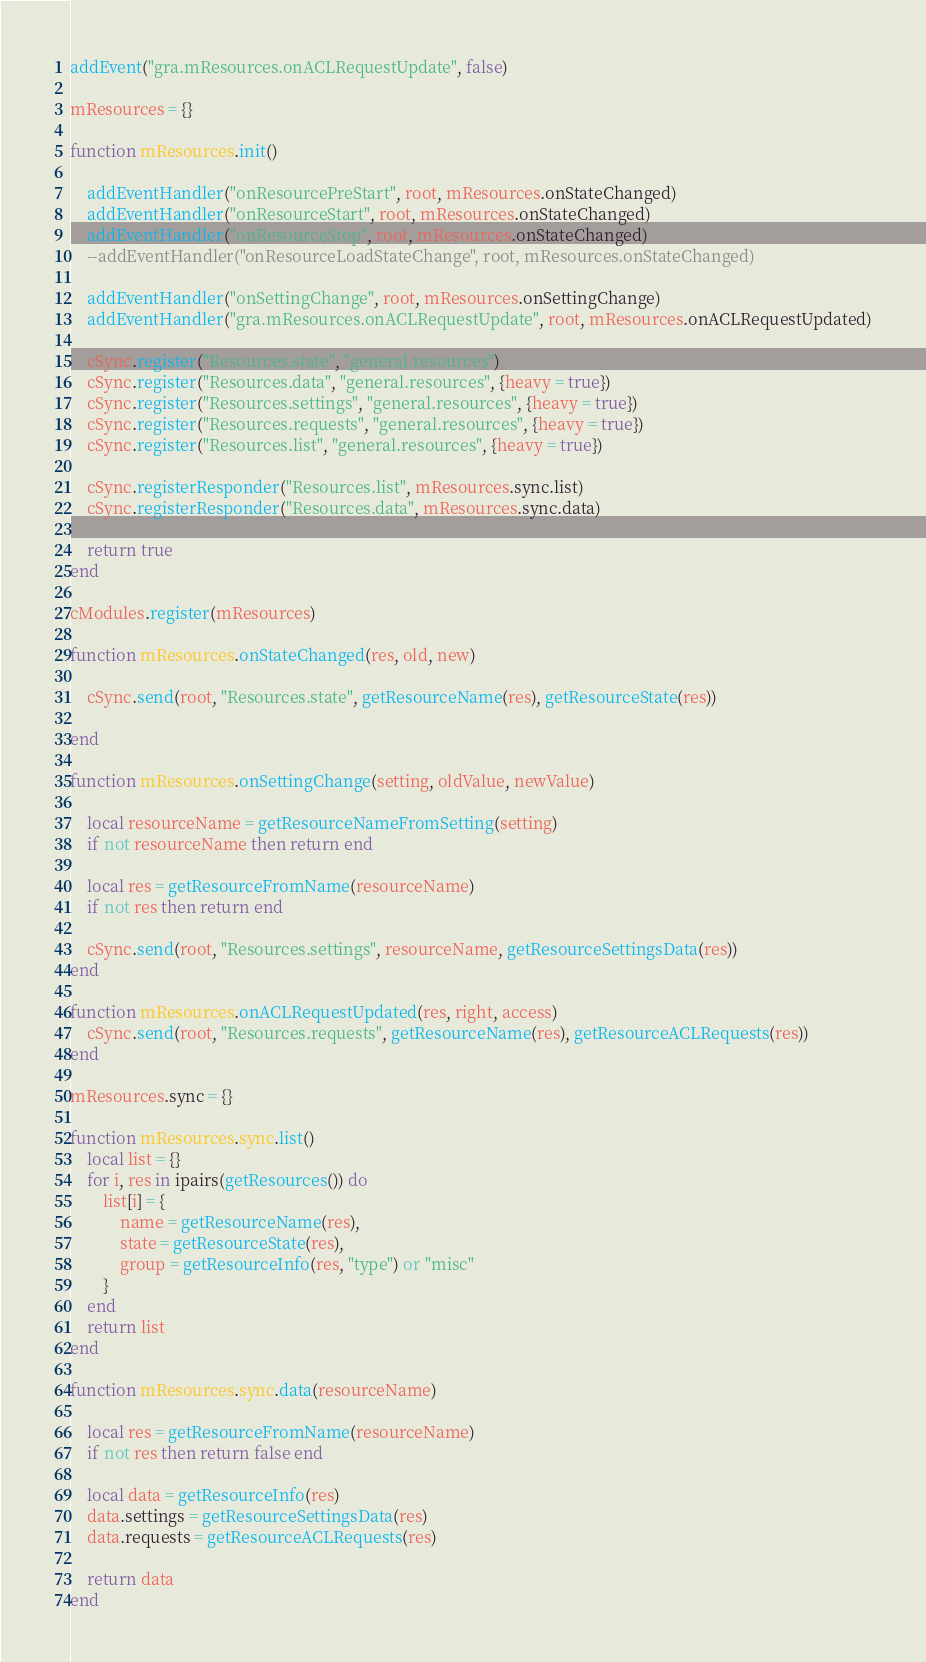<code> <loc_0><loc_0><loc_500><loc_500><_Lua_>
addEvent("gra.mResources.onACLRequestUpdate", false)

mResources = {}

function mResources.init()
	
	addEventHandler("onResourcePreStart", root, mResources.onStateChanged)
	addEventHandler("onResourceStart", root, mResources.onStateChanged)
	addEventHandler("onResourceStop", root, mResources.onStateChanged)
	--addEventHandler("onResourceLoadStateChange", root, mResources.onStateChanged)

	addEventHandler("onSettingChange", root, mResources.onSettingChange)
	addEventHandler("gra.mResources.onACLRequestUpdate", root, mResources.onACLRequestUpdated)

	cSync.register("Resources.state", "general.resources")
	cSync.register("Resources.data", "general.resources", {heavy = true})
	cSync.register("Resources.settings", "general.resources", {heavy = true})
	cSync.register("Resources.requests", "general.resources", {heavy = true})
	cSync.register("Resources.list", "general.resources", {heavy = true})

	cSync.registerResponder("Resources.list", mResources.sync.list)
	cSync.registerResponder("Resources.data", mResources.sync.data)

	return true
end

cModules.register(mResources)

function mResources.onStateChanged(res, old, new)

	cSync.send(root, "Resources.state", getResourceName(res), getResourceState(res))

end

function mResources.onSettingChange(setting, oldValue, newValue)
	
	local resourceName = getResourceNameFromSetting(setting)
	if not resourceName then return end

	local res = getResourceFromName(resourceName)
	if not res then return end

	cSync.send(root, "Resources.settings", resourceName, getResourceSettingsData(res))
end

function mResources.onACLRequestUpdated(res, right, access)
	cSync.send(root, "Resources.requests", getResourceName(res), getResourceACLRequests(res))
end

mResources.sync = {}

function mResources.sync.list()
	local list = {}
	for i, res in ipairs(getResources()) do
		list[i] = {
			name = getResourceName(res),
			state = getResourceState(res),
			group = getResourceInfo(res, "type") or "misc"
		}
	end
	return list
end

function mResources.sync.data(resourceName)

	local res = getResourceFromName(resourceName)
	if not res then return false end

	local data = getResourceInfo(res)
	data.settings = getResourceSettingsData(res)
	data.requests = getResourceACLRequests(res)

	return data
end</code> 